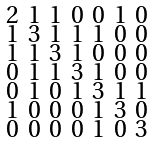<formula> <loc_0><loc_0><loc_500><loc_500>\begin{smallmatrix} 2 & 1 & 1 & 0 & 0 & 1 & 0 \\ 1 & 3 & 1 & 1 & 1 & 0 & 0 \\ 1 & 1 & 3 & 1 & 0 & 0 & 0 \\ 0 & 1 & 1 & 3 & 1 & 0 & 0 \\ 0 & 1 & 0 & 1 & 3 & 1 & 1 \\ 1 & 0 & 0 & 0 & 1 & 3 & 0 \\ 0 & 0 & 0 & 0 & 1 & 0 & 3 \end{smallmatrix}</formula> 